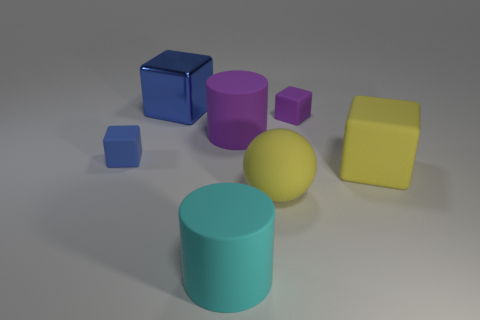What is the material of the large blue thing that is the same shape as the tiny purple thing?
Give a very brief answer. Metal. There is a rubber thing that is left of the large blue metallic cube; does it have the same shape as the tiny matte thing on the right side of the big blue cube?
Keep it short and to the point. Yes. What is the shape of the small blue thing that is made of the same material as the big yellow sphere?
Offer a terse response. Cube. There is a big rubber thing that is behind the large sphere and left of the big rubber block; what color is it?
Your answer should be compact. Purple. Do the ball to the right of the large shiny object and the big purple object have the same material?
Make the answer very short. Yes. Are there fewer big yellow matte things to the left of the big blue block than small cyan rubber objects?
Give a very brief answer. No. Is there a blue thing that has the same material as the sphere?
Provide a short and direct response. Yes. There is a rubber sphere; is it the same size as the matte cylinder that is behind the cyan cylinder?
Your response must be concise. Yes. Are there any other tiny blocks of the same color as the shiny cube?
Your answer should be very brief. Yes. Is the material of the cyan thing the same as the large blue thing?
Offer a terse response. No. 